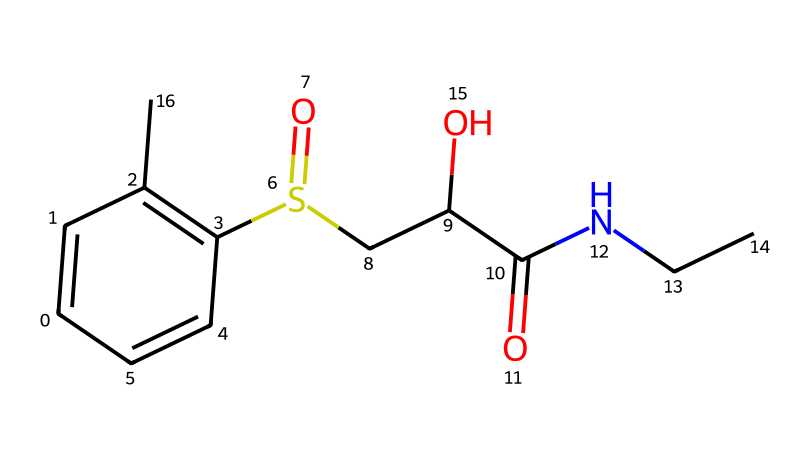What is the name of this compound? The SMILES representation corresponds to modafinil, which is commonly known as a wakefulness-promoting agent.
Answer: modafinil How many carbon atoms are in the structure? By analyzing the SMILES string, we can count 13 carbon atoms present in various parts of the structure.
Answer: 13 What functional group is present in this compound? The SMILES notation indicates the presence of a sulfonyl group (S(=O)) as well as an amide group (C(=O)N).
Answer: sulfonyl How many oxygen atoms are present in this compound? From the SMILES representation, we can identify a total of 4 oxygen atoms. Two are part of the sulfonyl group and two are in the hydroxyl (-OH) and amide functional groups.
Answer: 4 What type of medicinal effect is modafinil known for? Modafinil is primarily known for its stimulant properties, aiding in cognitive enhancement and promoting wakefulness.
Answer: stimulant What is the relationship between the sulfonyl group and the compound's pharmacological activity? The sulfonyl group is critical for modafinil's activity as it plays a key role in the mechanism of action, enhancing the drug's binding interaction with target neurotransmitters.
Answer: mechanism of action Is there a hydroxyl (-OH) group present in this structure? Yes, the presence of the hydroxyl group (indicated by -OH) is clear from the structure, specifically noted in the SMILES string.
Answer: yes 